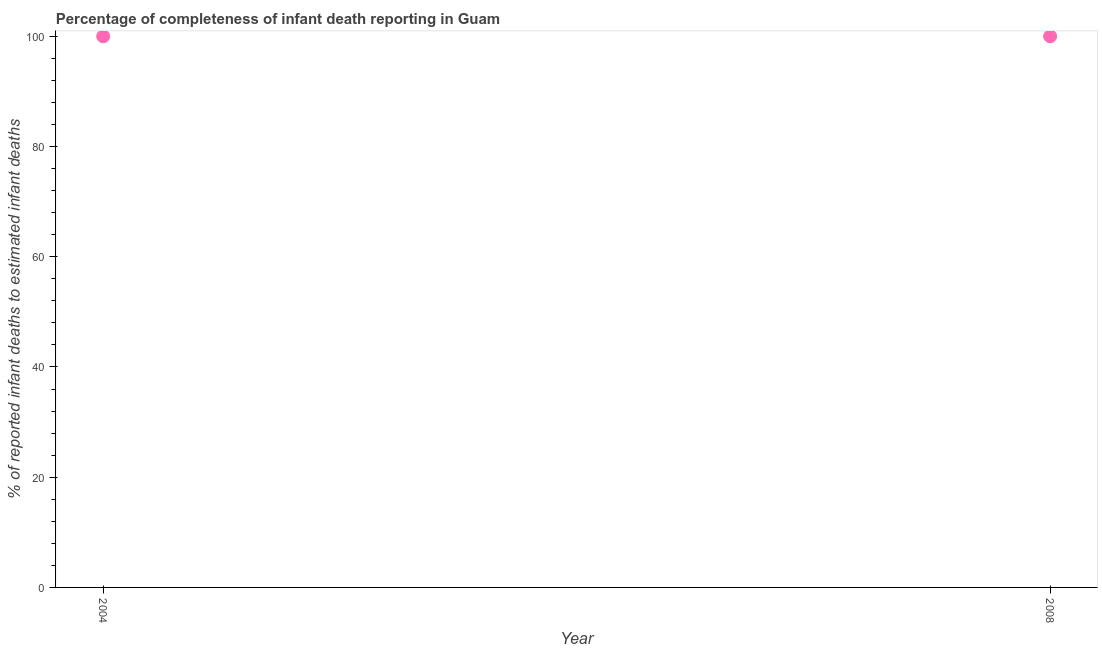What is the completeness of infant death reporting in 2008?
Offer a very short reply. 100. Across all years, what is the maximum completeness of infant death reporting?
Give a very brief answer. 100. Across all years, what is the minimum completeness of infant death reporting?
Keep it short and to the point. 100. In which year was the completeness of infant death reporting maximum?
Your response must be concise. 2004. What is the sum of the completeness of infant death reporting?
Your answer should be compact. 200. What is the average completeness of infant death reporting per year?
Provide a succinct answer. 100. What is the median completeness of infant death reporting?
Your answer should be very brief. 100. In how many years, is the completeness of infant death reporting greater than the average completeness of infant death reporting taken over all years?
Your response must be concise. 0. Does the completeness of infant death reporting monotonically increase over the years?
Ensure brevity in your answer.  No. How many dotlines are there?
Provide a short and direct response. 1. How many years are there in the graph?
Keep it short and to the point. 2. Does the graph contain grids?
Make the answer very short. No. What is the title of the graph?
Offer a terse response. Percentage of completeness of infant death reporting in Guam. What is the label or title of the Y-axis?
Provide a short and direct response. % of reported infant deaths to estimated infant deaths. What is the % of reported infant deaths to estimated infant deaths in 2008?
Offer a terse response. 100. What is the ratio of the % of reported infant deaths to estimated infant deaths in 2004 to that in 2008?
Your response must be concise. 1. 